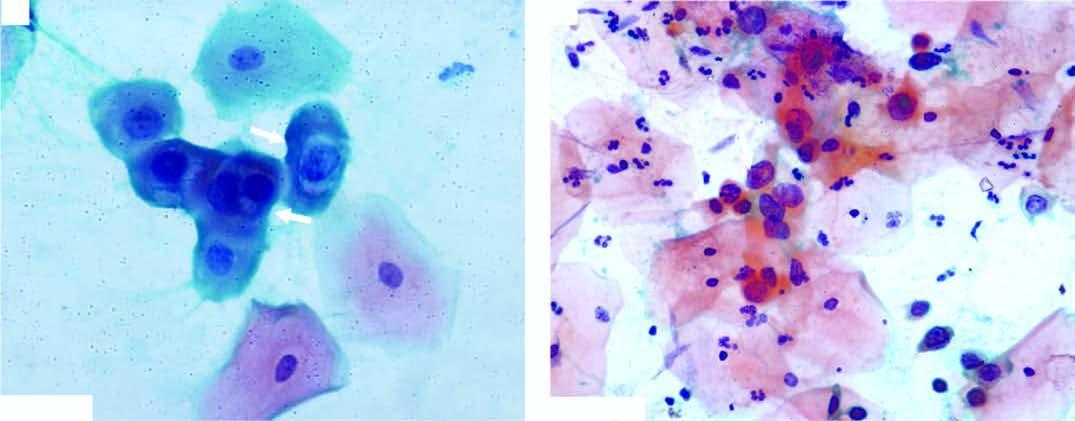what shows numerous pmns?
Answer the question using a single word or phrase. Background 